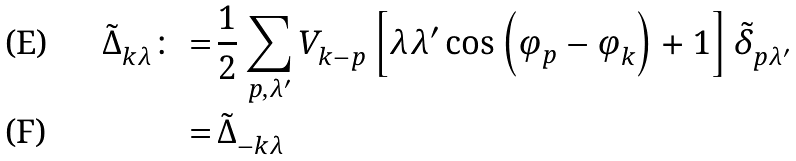<formula> <loc_0><loc_0><loc_500><loc_500>\tilde { \Delta } ^ { \ } _ { k \lambda } \colon = & \, \frac { 1 } { 2 } \sum _ { p , \lambda ^ { \prime } } V ^ { \ } _ { k - p } \left [ \lambda \lambda ^ { \prime } \cos \left ( \varphi ^ { \ } _ { p } - \varphi ^ { \ } _ { k } \right ) + 1 \right ] \tilde { \delta } ^ { \ } _ { p \lambda ^ { \prime } } \\ = & \, \tilde { \Delta } ^ { \ } _ { - k \lambda }</formula> 